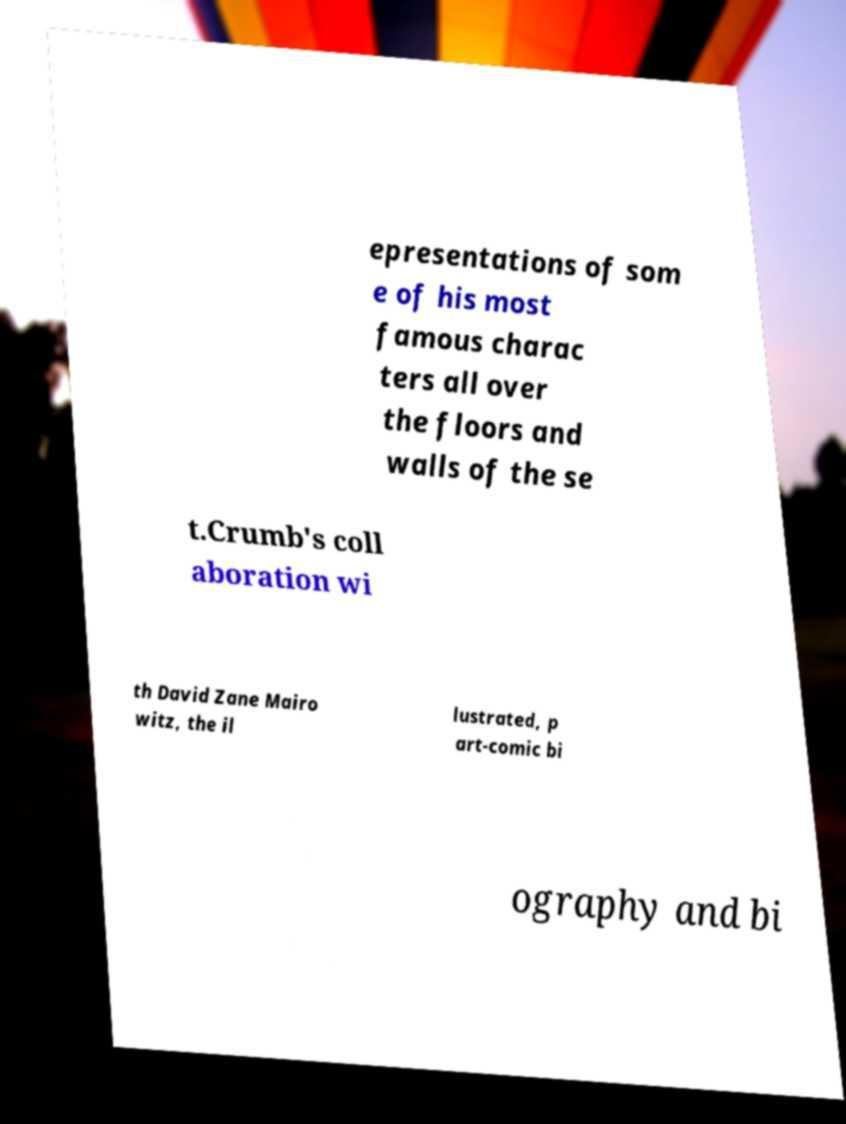Could you assist in decoding the text presented in this image and type it out clearly? epresentations of som e of his most famous charac ters all over the floors and walls of the se t.Crumb's coll aboration wi th David Zane Mairo witz, the il lustrated, p art-comic bi ography and bi 